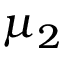<formula> <loc_0><loc_0><loc_500><loc_500>\mu _ { 2 }</formula> 